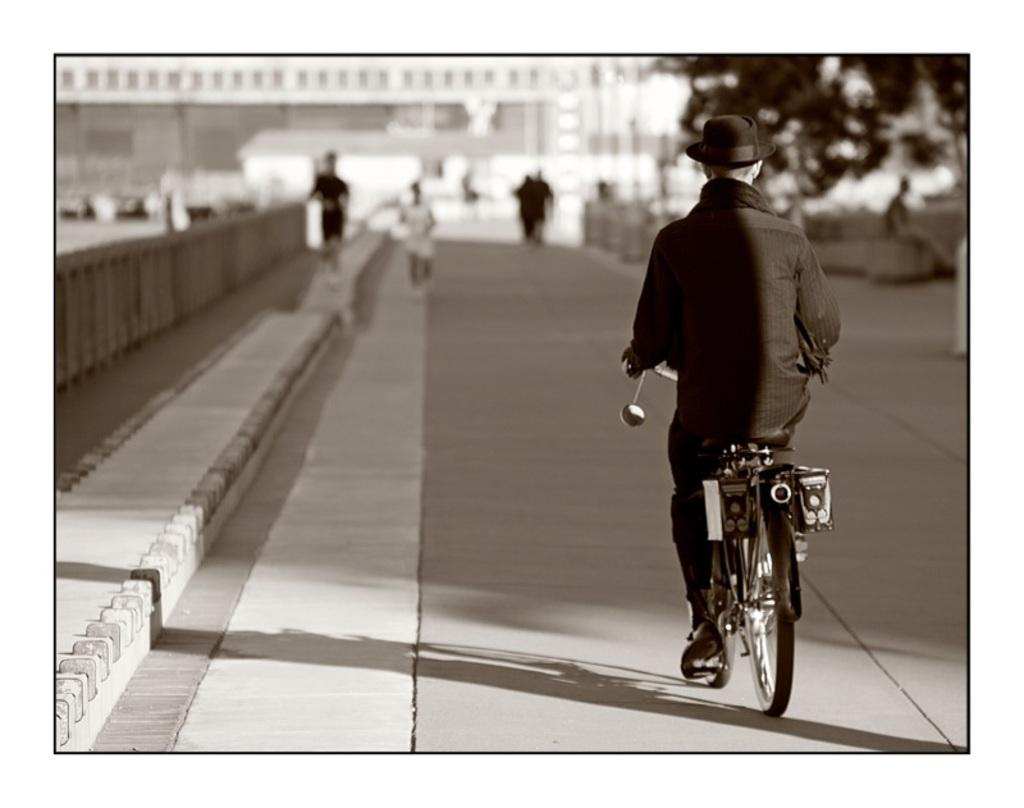What is located on the right side of the image? There is a road on the right side of the image. What can be seen on the road in the image? There is a man riding a bicycle in the image. What color is the bicycle? The bicycle is black in color. How many geese are walking on the road in the image? There are no geese present in the image; it features a man riding a black bicycle on the road. What type of suit is the goose wearing in the image? There is no goose or suit present in the image. 